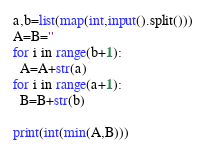Convert code to text. <code><loc_0><loc_0><loc_500><loc_500><_Python_>a,b=list(map(int,input().split()))
A=B=''
for i in range(b+1):
  A=A+str(a)
for i in range(a+1):
  B=B+str(b)

print(int(min(A,B)))
</code> 